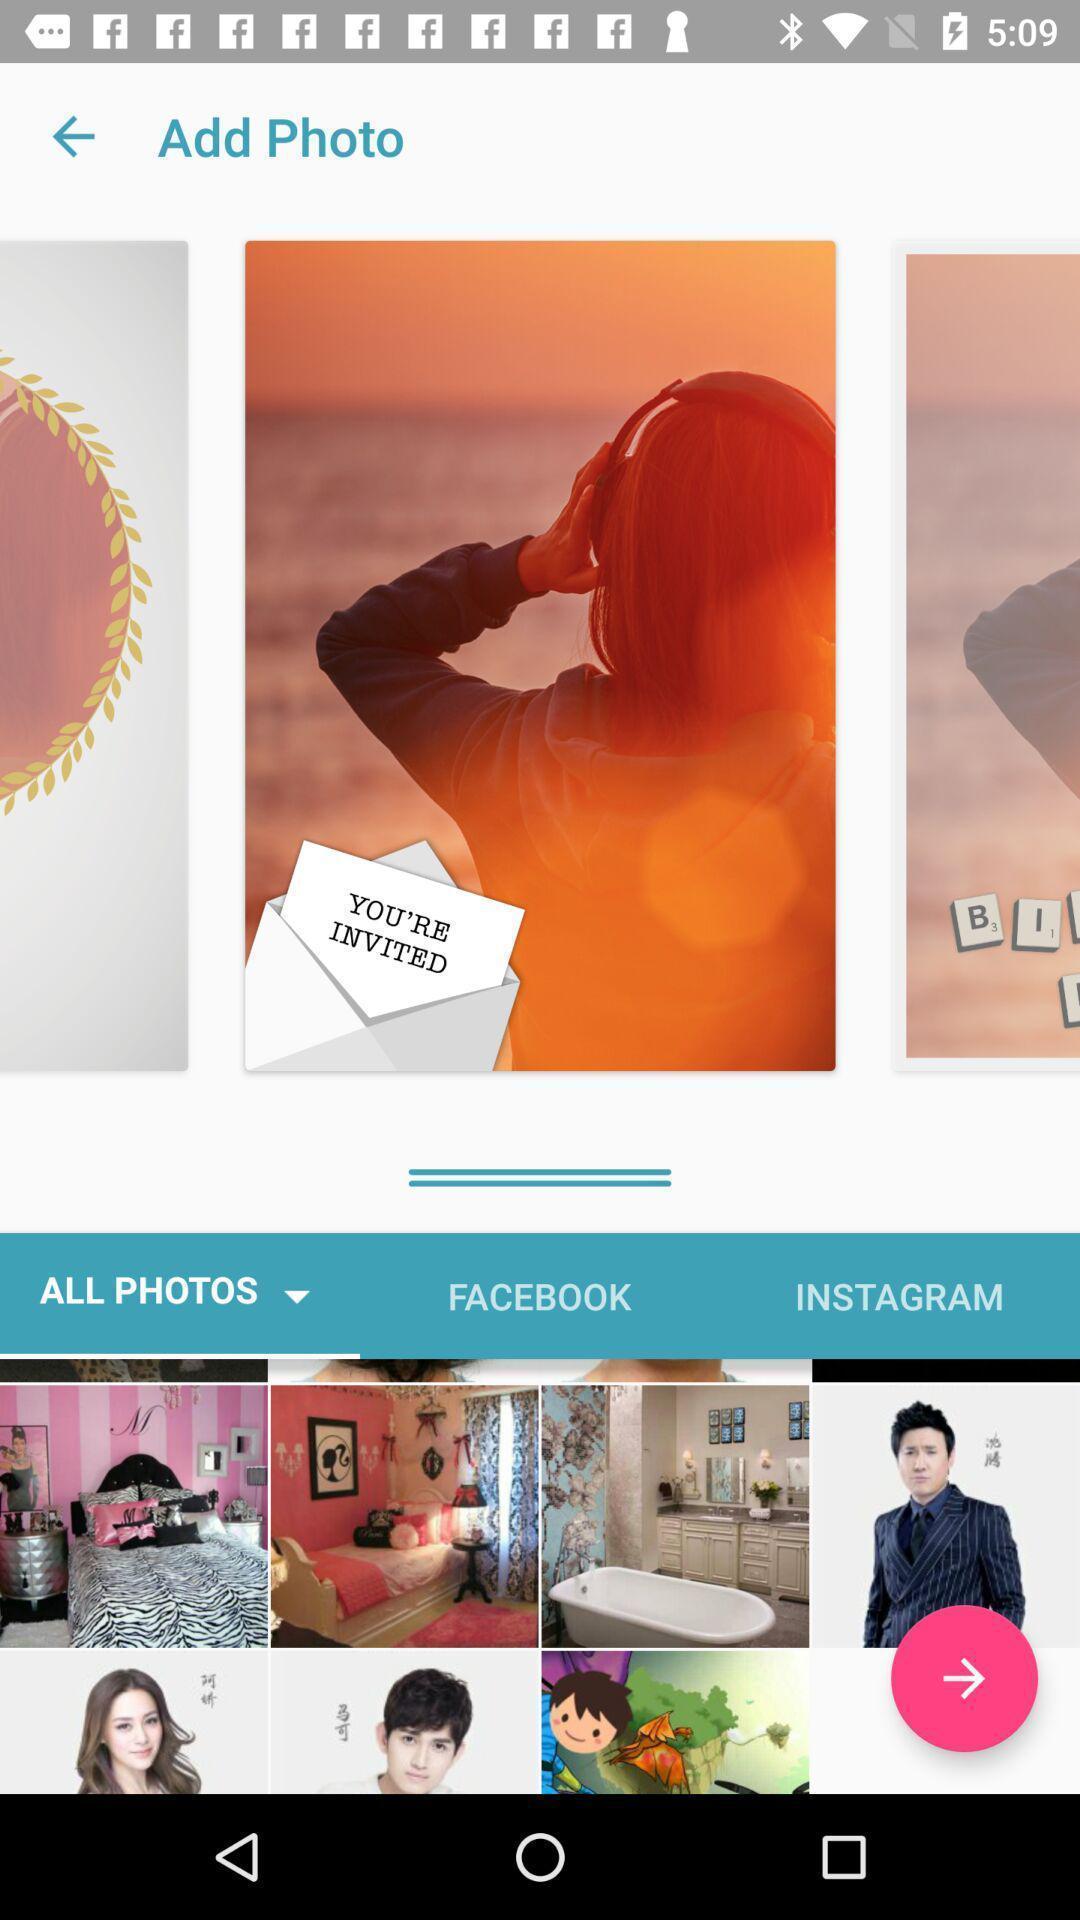Tell me what you see in this picture. Page showing different photos to add. 